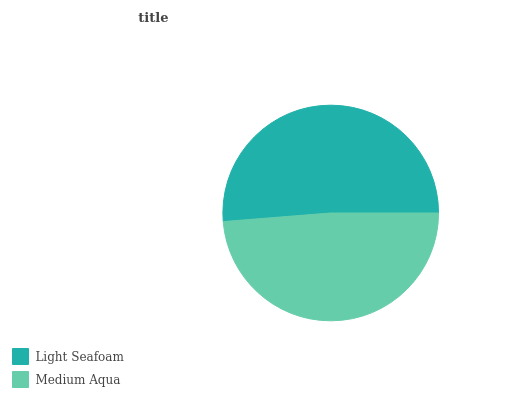Is Medium Aqua the minimum?
Answer yes or no. Yes. Is Light Seafoam the maximum?
Answer yes or no. Yes. Is Medium Aqua the maximum?
Answer yes or no. No. Is Light Seafoam greater than Medium Aqua?
Answer yes or no. Yes. Is Medium Aqua less than Light Seafoam?
Answer yes or no. Yes. Is Medium Aqua greater than Light Seafoam?
Answer yes or no. No. Is Light Seafoam less than Medium Aqua?
Answer yes or no. No. Is Light Seafoam the high median?
Answer yes or no. Yes. Is Medium Aqua the low median?
Answer yes or no. Yes. Is Medium Aqua the high median?
Answer yes or no. No. Is Light Seafoam the low median?
Answer yes or no. No. 